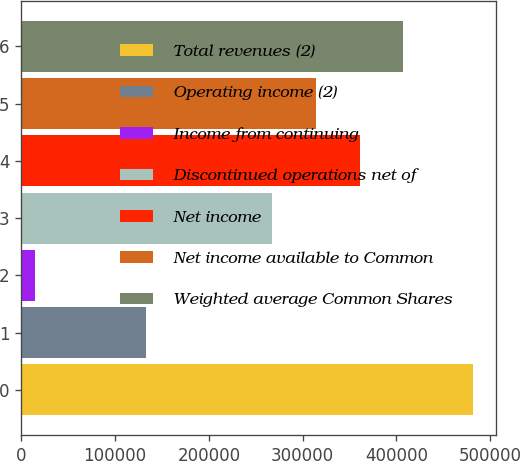<chart> <loc_0><loc_0><loc_500><loc_500><bar_chart><fcel>Total revenues (2)<fcel>Operating income (2)<fcel>Income from continuing<fcel>Discontinued operations net of<fcel>Net income<fcel>Net income available to Common<fcel>Weighted average Common Shares<nl><fcel>481619<fcel>132946<fcel>14924<fcel>267477<fcel>360816<fcel>314146<fcel>407486<nl></chart> 